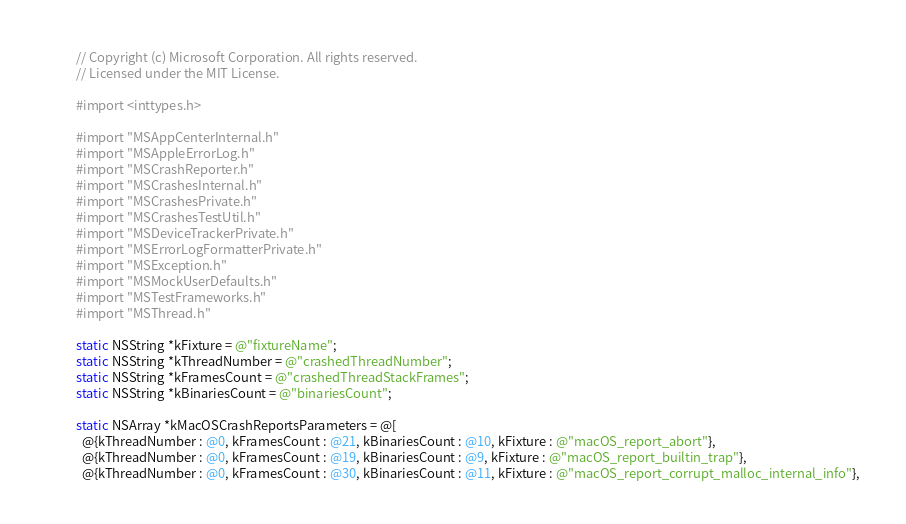<code> <loc_0><loc_0><loc_500><loc_500><_ObjectiveC_>// Copyright (c) Microsoft Corporation. All rights reserved.
// Licensed under the MIT License.

#import <inttypes.h>

#import "MSAppCenterInternal.h"
#import "MSAppleErrorLog.h"
#import "MSCrashReporter.h"
#import "MSCrashesInternal.h"
#import "MSCrashesPrivate.h"
#import "MSCrashesTestUtil.h"
#import "MSDeviceTrackerPrivate.h"
#import "MSErrorLogFormatterPrivate.h"
#import "MSException.h"
#import "MSMockUserDefaults.h"
#import "MSTestFrameworks.h"
#import "MSThread.h"

static NSString *kFixture = @"fixtureName";
static NSString *kThreadNumber = @"crashedThreadNumber";
static NSString *kFramesCount = @"crashedThreadStackFrames";
static NSString *kBinariesCount = @"binariesCount";

static NSArray *kMacOSCrashReportsParameters = @[
  @{kThreadNumber : @0, kFramesCount : @21, kBinariesCount : @10, kFixture : @"macOS_report_abort"},
  @{kThreadNumber : @0, kFramesCount : @19, kBinariesCount : @9, kFixture : @"macOS_report_builtin_trap"},
  @{kThreadNumber : @0, kFramesCount : @30, kBinariesCount : @11, kFixture : @"macOS_report_corrupt_malloc_internal_info"},</code> 